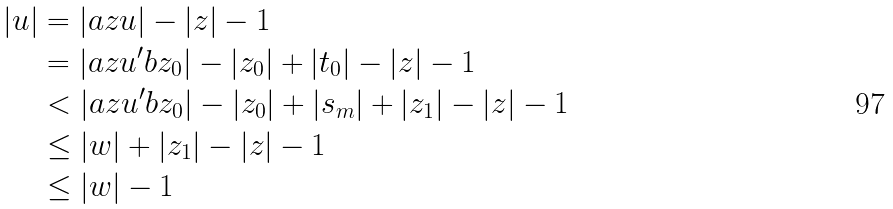<formula> <loc_0><loc_0><loc_500><loc_500>| u | & = | a z u | - | z | - 1 \\ & = | a z u ^ { \prime } b z _ { 0 } | - | z _ { 0 } | + | t _ { 0 } | - | z | - 1 \\ & < | a z u ^ { \prime } b z _ { 0 } | - | z _ { 0 } | + | s _ { m } | + | z _ { 1 } | - | z | - 1 \\ & \leq | w | + | z _ { 1 } | - | z | - 1 \\ & \leq | w | - 1</formula> 